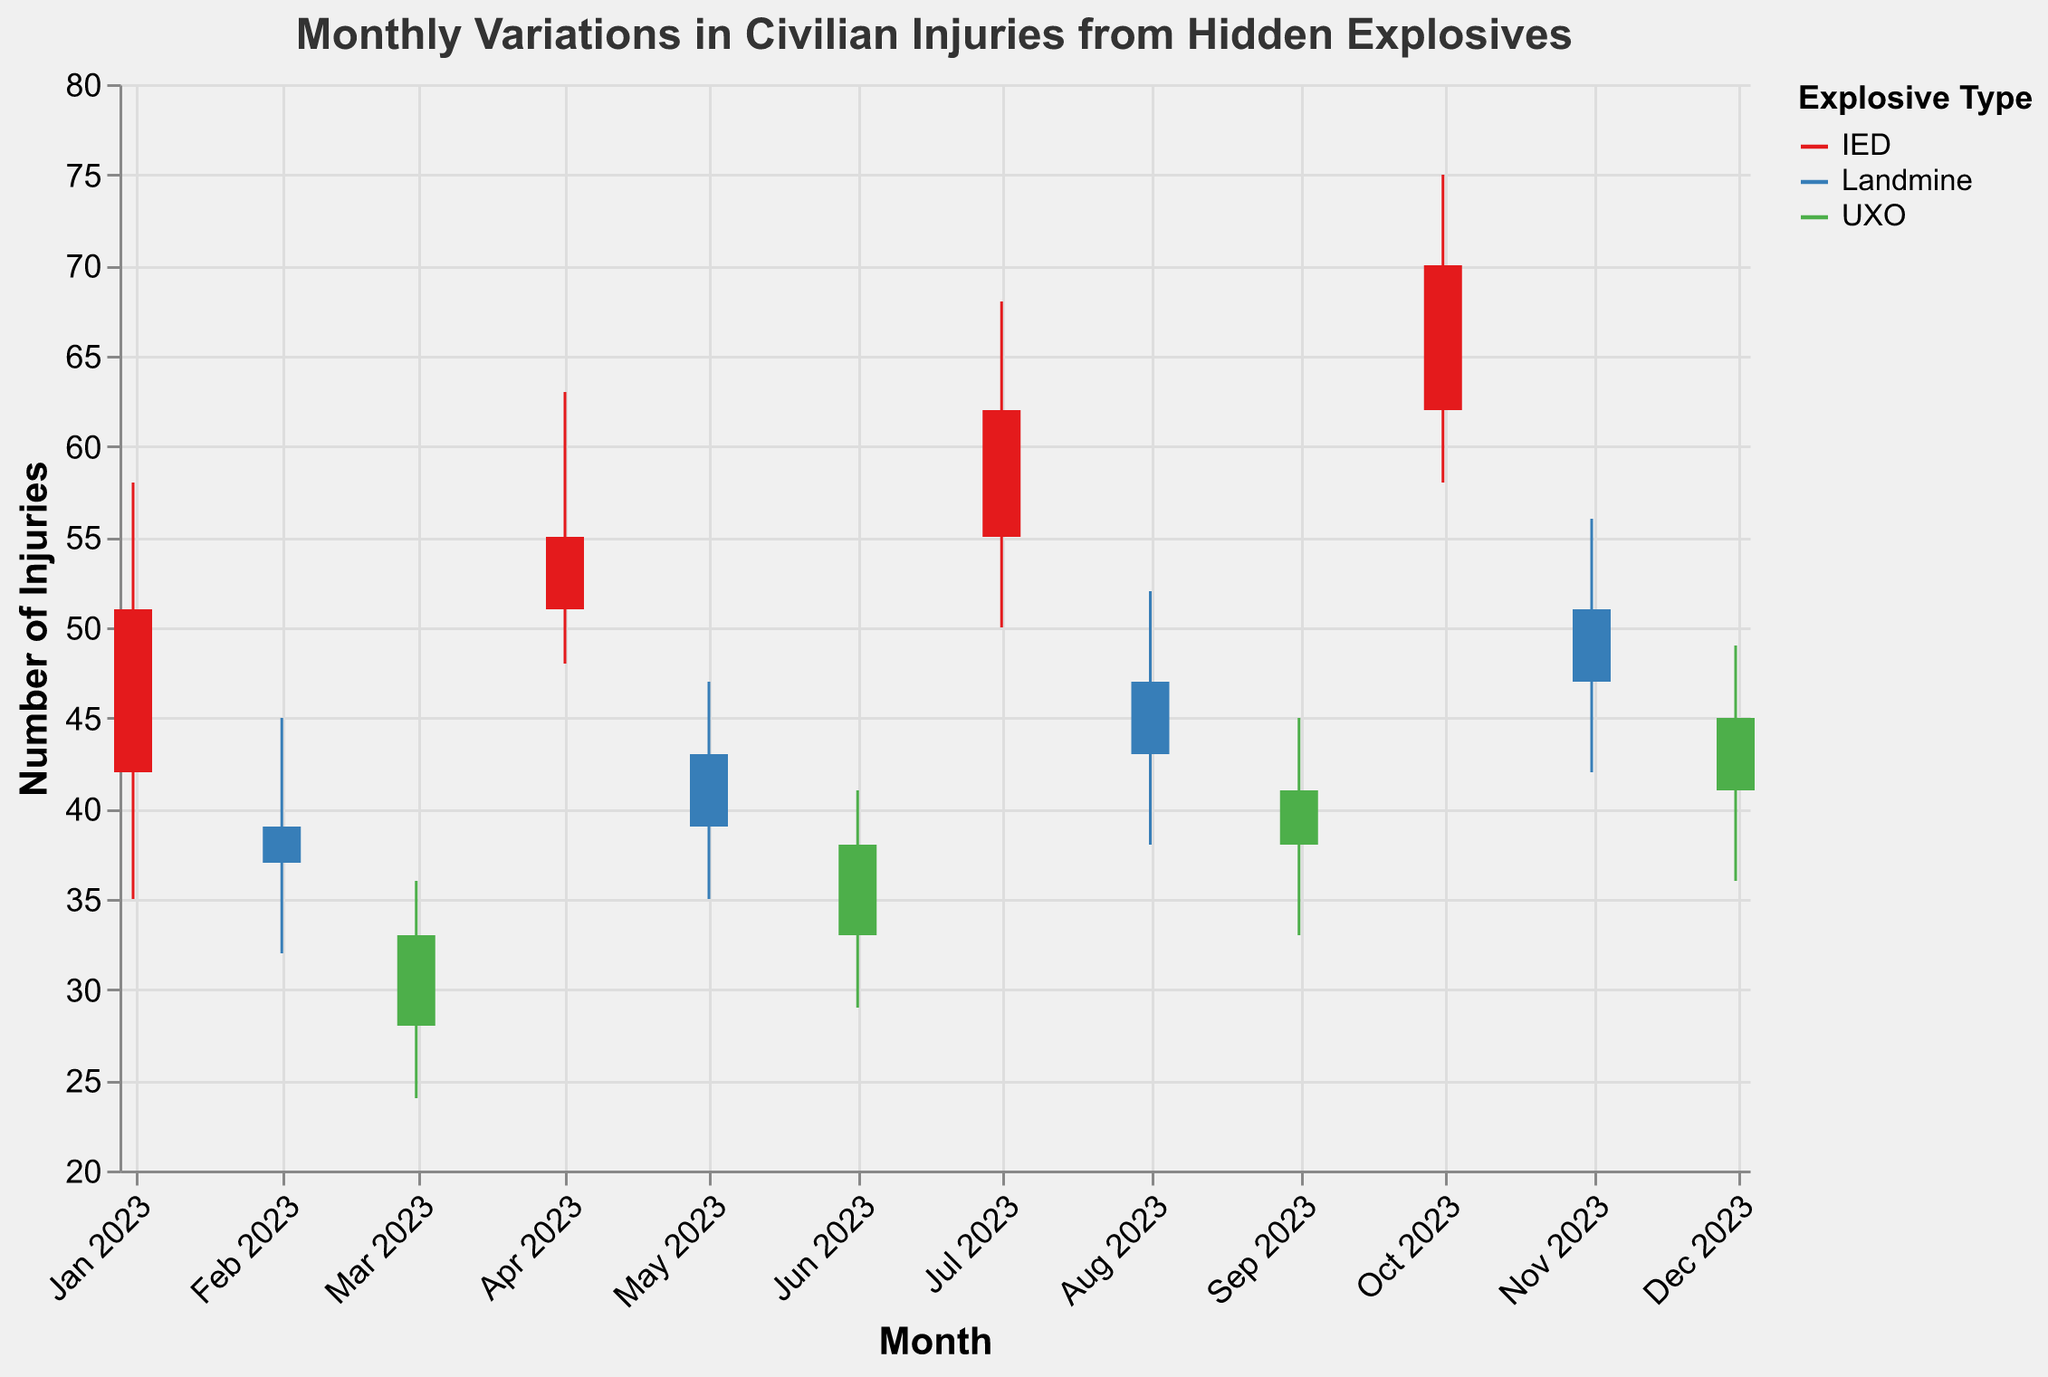Which month had the highest number of injuries due to IEDs? The plot shows OHLC data for each month; the "High" value represents the highest number of injuries. For IEDs, October (2023-10) has the highest "High" value of 75.
Answer: October 2023 What was the lowest number of injuries from Landmines in 2023? The plot shows OHLC data, where the "Low" value represents the lowest number of injuries. For Landmines, February (2023-02) has the lowest "Low" value of 32.
Answer: February 2023 Compare the opening injuries of UXO from June and December. Which month had a higher opening value? June (2023-06) has an "Open" value of 33, whereas December (2023-12) has an "Open" value of 41. So, December is higher.
Answer: December 2023 How many months recorded a closing value above 50 for IEDs? The IED "Close" values need to be checked for each month. The months are April (55), July (62), and October (70). Thus, three months had a closing value above 50.
Answer: 3 What is the average "High" value for injuries caused by UXOs? The "High" values for UXO are 36 (March), 41 (June), 45 (September), and 49 (December). The average is (36 + 41 + 45 + 49) / 4 = 42.75.
Answer: 42.75 Which type of explosive device had the largest range in injuries (difference between High and Low) in any single month? For each month, the range is "High" - "Low". IED in October has a range of 75 - 58 = 17, which is the largest among all devices across months.
Answer: IED in October In which month did Landmines and UXOs have the same closing value? The plot shows "Close" values for each month. In November (2023-11) for Landmines and December (2023-12) for UXOs, both have a close value of 51.
Answer: None What was the total number of injuries from Hidden Explosives in April and August combined? For April (IED), the "Close" value is 55. For August (Landmine), the "Close" value is 47. Combined, it is 55 + 47 = 102.
Answer: 102 During which month did IEDs have the smallest difference between the opening and closing values? The difference for each month needs to be calculated. For IED: Jan (9), Apr (4), Jul (7), Oct (8). April with a difference of 4 is the smallest.
Answer: April 2023 